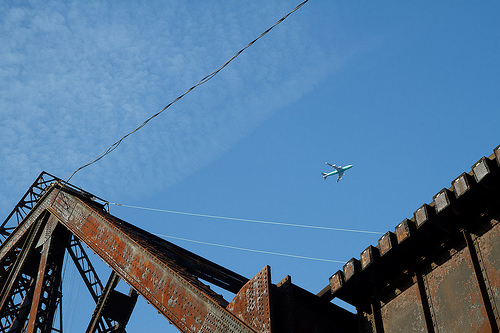What's the object you see in the sky? In the sky, you can see an airplane flying high above. Can you describe the bridge in more detail? The bridge is constructed from rusted steel beams, showcasing an industrial aesthetic. Parts of the structure exhibit signs of wear and tear, indicating it has served its purpose for many years. 